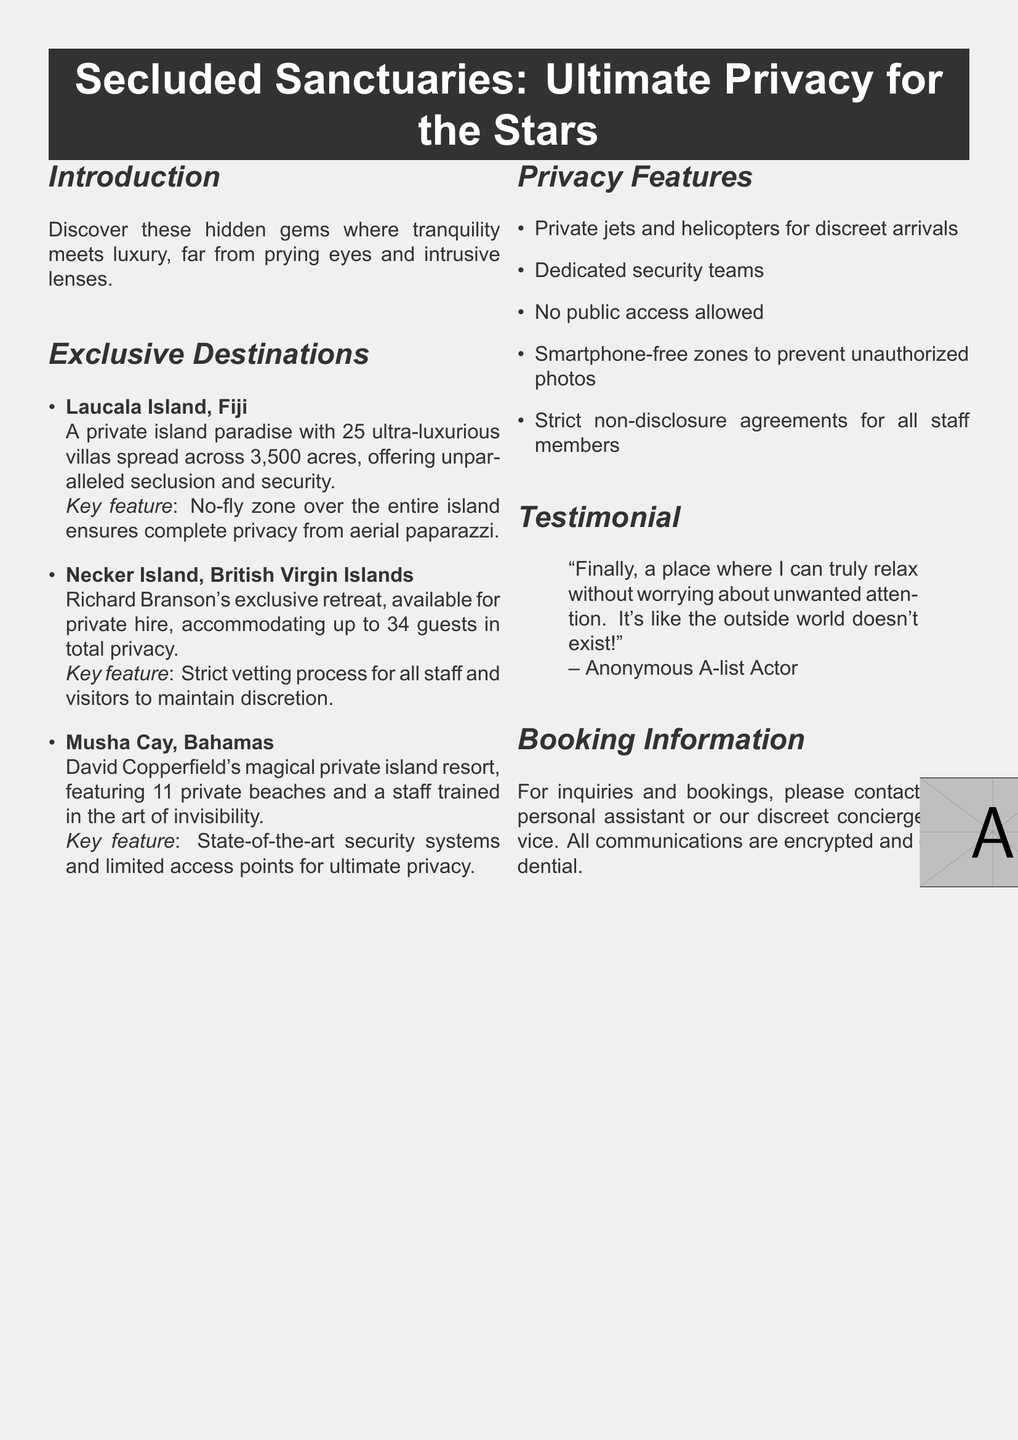what is the first destination listed? The first destination mentioned in the Exclusive Destinations section is Laucala Island, Fiji.
Answer: Laucala Island, Fiji how many private beaches are at Musha Cay? The document states that Musha Cay features 11 private beaches.
Answer: 11 what is a unique feature of Laucala Island? The document highlights that there is a no-fly zone over the entire island to ensure privacy.
Answer: No-fly zone who owns Necker Island? Richard Branson is the owner of Necker Island as per the document.
Answer: Richard Branson what kind of zones are established for smartphones? The document specifies that there are smartphone-free zones to prevent unauthorized photos.
Answer: Smartphone-free zones which celebrity provided a testimonial? The testimonial is attributed to an anonymous A-list actor, according to the document.
Answer: Anonymous A-list Actor what is the total guest accommodation on Necker Island? Necker Island accommodates up to 34 guests as mentioned in the document.
Answer: 34 guests what is the main focus of this catalog? This catalog primarily focuses on secluded vacation destinations for privacy-seeking celebrities.
Answer: Secluded vacation destinations how are communications handled for bookings? The document states that all communications are encrypted and confidential for bookings.
Answer: Encrypted and confidential 